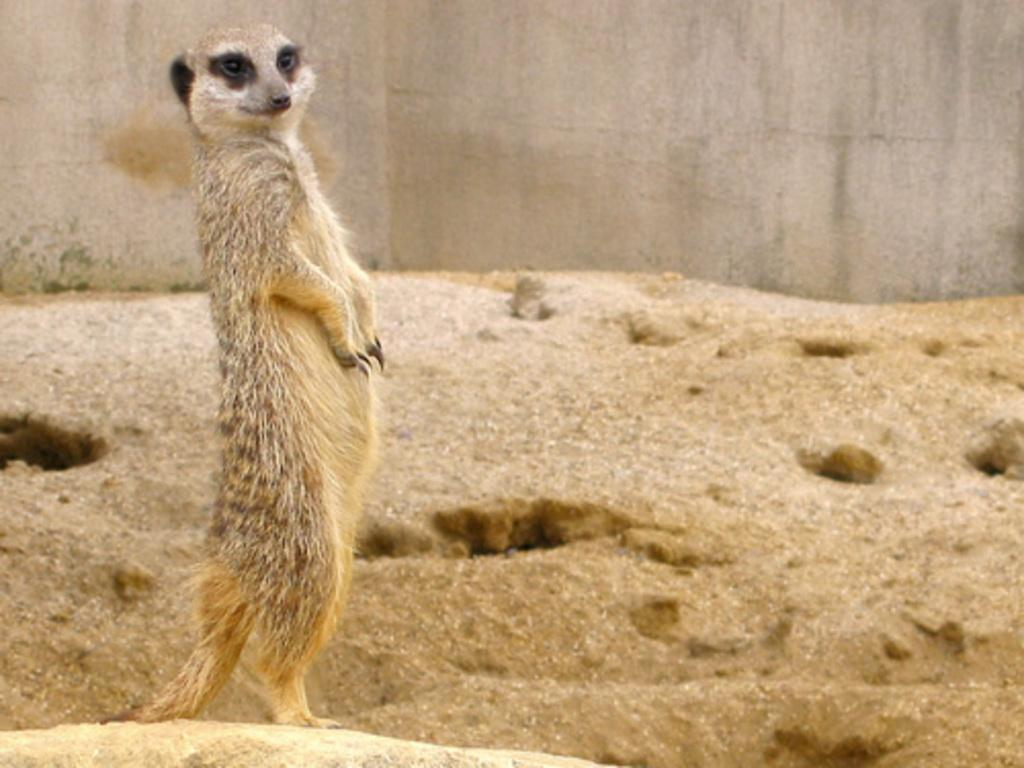What type of creature is in the image? There is an animal in the image. What is the animal's position in relation to the ground? The animal is standing on the ground. What other element can be seen in the image? There is a wall visible in the image. What month is depicted in the image? There is no specific month depicted in the image; it only shows an animal standing on the ground and a wall. Is there a mask being worn by the animal in the image? There is no mask present in the image; it only features an animal and a wall. 